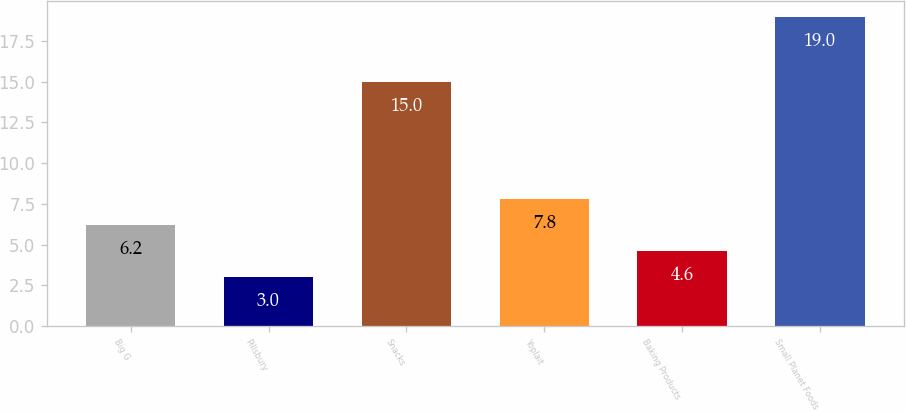Convert chart. <chart><loc_0><loc_0><loc_500><loc_500><bar_chart><fcel>Big G<fcel>Pillsbury<fcel>Snacks<fcel>Yoplait<fcel>Baking Products<fcel>Small Planet Foods<nl><fcel>6.2<fcel>3<fcel>15<fcel>7.8<fcel>4.6<fcel>19<nl></chart> 